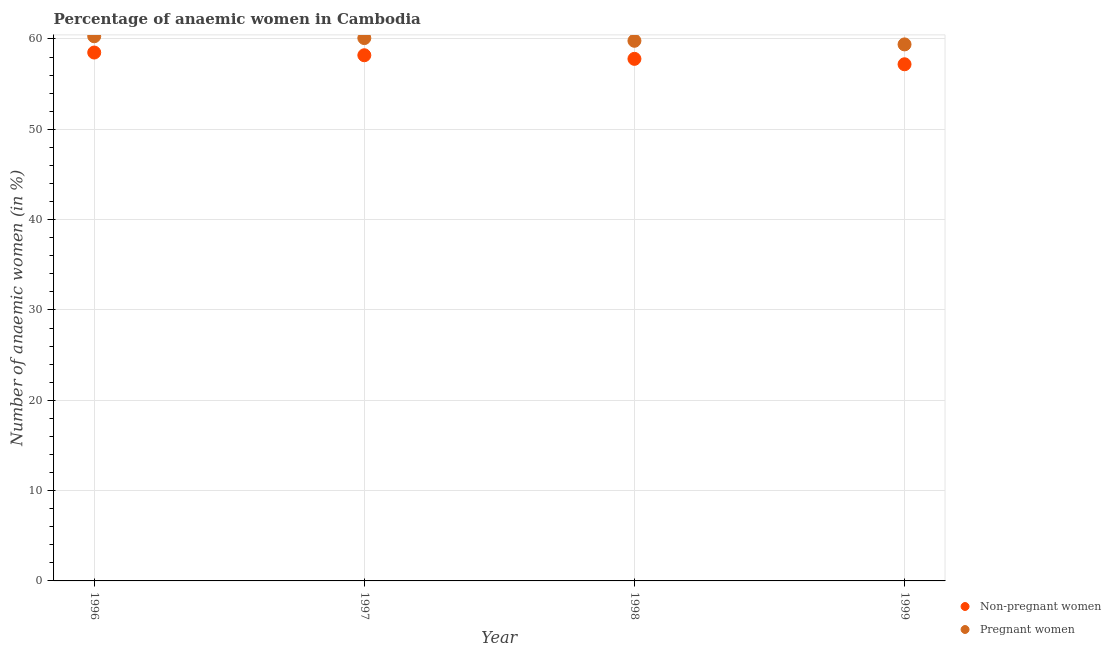How many different coloured dotlines are there?
Ensure brevity in your answer.  2. Is the number of dotlines equal to the number of legend labels?
Offer a very short reply. Yes. What is the percentage of non-pregnant anaemic women in 1996?
Offer a very short reply. 58.5. Across all years, what is the maximum percentage of non-pregnant anaemic women?
Give a very brief answer. 58.5. Across all years, what is the minimum percentage of non-pregnant anaemic women?
Offer a terse response. 57.2. In which year was the percentage of pregnant anaemic women maximum?
Offer a terse response. 1996. What is the total percentage of non-pregnant anaemic women in the graph?
Offer a terse response. 231.7. What is the difference between the percentage of non-pregnant anaemic women in 1996 and that in 1998?
Keep it short and to the point. 0.7. What is the difference between the percentage of non-pregnant anaemic women in 1997 and the percentage of pregnant anaemic women in 1996?
Offer a terse response. -2.1. What is the average percentage of non-pregnant anaemic women per year?
Your response must be concise. 57.92. In the year 1996, what is the difference between the percentage of non-pregnant anaemic women and percentage of pregnant anaemic women?
Your answer should be compact. -1.8. What is the ratio of the percentage of pregnant anaemic women in 1998 to that in 1999?
Offer a very short reply. 1.01. Is the percentage of non-pregnant anaemic women in 1998 less than that in 1999?
Offer a terse response. No. Is the difference between the percentage of pregnant anaemic women in 1996 and 1998 greater than the difference between the percentage of non-pregnant anaemic women in 1996 and 1998?
Offer a very short reply. No. What is the difference between the highest and the second highest percentage of pregnant anaemic women?
Offer a terse response. 0.2. What is the difference between the highest and the lowest percentage of pregnant anaemic women?
Keep it short and to the point. 0.9. In how many years, is the percentage of non-pregnant anaemic women greater than the average percentage of non-pregnant anaemic women taken over all years?
Ensure brevity in your answer.  2. Is the sum of the percentage of pregnant anaemic women in 1996 and 1998 greater than the maximum percentage of non-pregnant anaemic women across all years?
Provide a short and direct response. Yes. How many dotlines are there?
Provide a short and direct response. 2. What is the difference between two consecutive major ticks on the Y-axis?
Provide a short and direct response. 10. Are the values on the major ticks of Y-axis written in scientific E-notation?
Ensure brevity in your answer.  No. Does the graph contain any zero values?
Your answer should be compact. No. Does the graph contain grids?
Your answer should be compact. Yes. Where does the legend appear in the graph?
Keep it short and to the point. Bottom right. How many legend labels are there?
Make the answer very short. 2. What is the title of the graph?
Your answer should be very brief. Percentage of anaemic women in Cambodia. What is the label or title of the X-axis?
Offer a terse response. Year. What is the label or title of the Y-axis?
Keep it short and to the point. Number of anaemic women (in %). What is the Number of anaemic women (in %) in Non-pregnant women in 1996?
Make the answer very short. 58.5. What is the Number of anaemic women (in %) in Pregnant women in 1996?
Ensure brevity in your answer.  60.3. What is the Number of anaemic women (in %) of Non-pregnant women in 1997?
Keep it short and to the point. 58.2. What is the Number of anaemic women (in %) in Pregnant women in 1997?
Your answer should be very brief. 60.1. What is the Number of anaemic women (in %) in Non-pregnant women in 1998?
Your response must be concise. 57.8. What is the Number of anaemic women (in %) of Pregnant women in 1998?
Ensure brevity in your answer.  59.8. What is the Number of anaemic women (in %) in Non-pregnant women in 1999?
Give a very brief answer. 57.2. What is the Number of anaemic women (in %) in Pregnant women in 1999?
Your answer should be very brief. 59.4. Across all years, what is the maximum Number of anaemic women (in %) of Non-pregnant women?
Give a very brief answer. 58.5. Across all years, what is the maximum Number of anaemic women (in %) in Pregnant women?
Your answer should be compact. 60.3. Across all years, what is the minimum Number of anaemic women (in %) in Non-pregnant women?
Your response must be concise. 57.2. Across all years, what is the minimum Number of anaemic women (in %) of Pregnant women?
Give a very brief answer. 59.4. What is the total Number of anaemic women (in %) in Non-pregnant women in the graph?
Your answer should be very brief. 231.7. What is the total Number of anaemic women (in %) of Pregnant women in the graph?
Offer a terse response. 239.6. What is the difference between the Number of anaemic women (in %) of Non-pregnant women in 1996 and that in 1997?
Provide a short and direct response. 0.3. What is the difference between the Number of anaemic women (in %) in Pregnant women in 1996 and that in 1997?
Ensure brevity in your answer.  0.2. What is the difference between the Number of anaemic women (in %) of Non-pregnant women in 1996 and that in 1998?
Ensure brevity in your answer.  0.7. What is the difference between the Number of anaemic women (in %) of Non-pregnant women in 1996 and that in 1999?
Your response must be concise. 1.3. What is the difference between the Number of anaemic women (in %) in Non-pregnant women in 1997 and that in 1998?
Your answer should be very brief. 0.4. What is the difference between the Number of anaemic women (in %) in Non-pregnant women in 1998 and that in 1999?
Ensure brevity in your answer.  0.6. What is the difference between the Number of anaemic women (in %) in Pregnant women in 1998 and that in 1999?
Your answer should be compact. 0.4. What is the difference between the Number of anaemic women (in %) in Non-pregnant women in 1996 and the Number of anaemic women (in %) in Pregnant women in 1998?
Make the answer very short. -1.3. What is the difference between the Number of anaemic women (in %) in Non-pregnant women in 1997 and the Number of anaemic women (in %) in Pregnant women in 1998?
Provide a succinct answer. -1.6. What is the difference between the Number of anaemic women (in %) of Non-pregnant women in 1998 and the Number of anaemic women (in %) of Pregnant women in 1999?
Your response must be concise. -1.6. What is the average Number of anaemic women (in %) of Non-pregnant women per year?
Provide a succinct answer. 57.92. What is the average Number of anaemic women (in %) of Pregnant women per year?
Keep it short and to the point. 59.9. In the year 1996, what is the difference between the Number of anaemic women (in %) of Non-pregnant women and Number of anaemic women (in %) of Pregnant women?
Your response must be concise. -1.8. In the year 1997, what is the difference between the Number of anaemic women (in %) in Non-pregnant women and Number of anaemic women (in %) in Pregnant women?
Your answer should be very brief. -1.9. In the year 1998, what is the difference between the Number of anaemic women (in %) of Non-pregnant women and Number of anaemic women (in %) of Pregnant women?
Your response must be concise. -2. What is the ratio of the Number of anaemic women (in %) of Non-pregnant women in 1996 to that in 1998?
Your response must be concise. 1.01. What is the ratio of the Number of anaemic women (in %) of Pregnant women in 1996 to that in 1998?
Offer a terse response. 1.01. What is the ratio of the Number of anaemic women (in %) in Non-pregnant women in 1996 to that in 1999?
Provide a short and direct response. 1.02. What is the ratio of the Number of anaemic women (in %) in Pregnant women in 1996 to that in 1999?
Your answer should be very brief. 1.02. What is the ratio of the Number of anaemic women (in %) in Pregnant women in 1997 to that in 1998?
Offer a terse response. 1. What is the ratio of the Number of anaemic women (in %) of Non-pregnant women in 1997 to that in 1999?
Offer a terse response. 1.02. What is the ratio of the Number of anaemic women (in %) of Pregnant women in 1997 to that in 1999?
Give a very brief answer. 1.01. What is the ratio of the Number of anaemic women (in %) of Non-pregnant women in 1998 to that in 1999?
Provide a short and direct response. 1.01. What is the difference between the highest and the second highest Number of anaemic women (in %) in Pregnant women?
Your answer should be very brief. 0.2. What is the difference between the highest and the lowest Number of anaemic women (in %) in Non-pregnant women?
Provide a short and direct response. 1.3. 